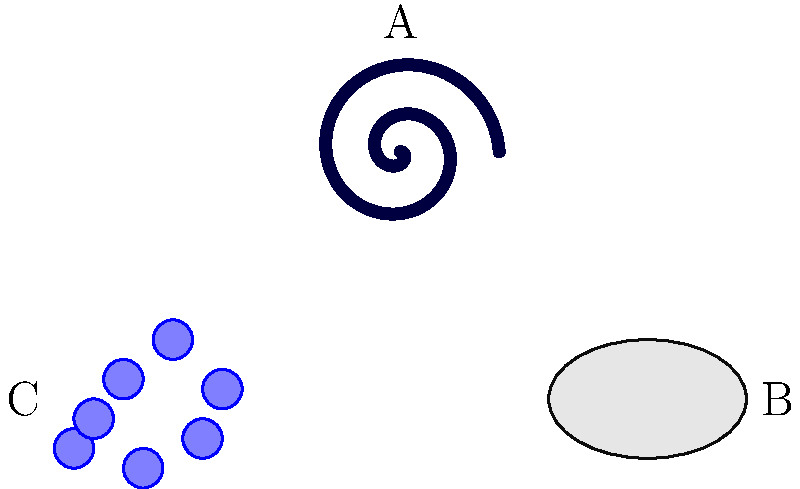As a botanist familiar with classification systems, consider the following galaxy types represented in the image above: A (spiral), B (elliptical), and C (irregular). Which of these galaxy types is most analogous to a plant species that has adapted to extreme environmental conditions, resulting in a non-uniform growth pattern? To answer this question, we need to consider the characteristics of each galaxy type and draw parallels to plant adaptations:

1. Spiral galaxies (A):
   - Have a distinct, organized structure with spiral arms
   - Analogous to plants with predictable, symmetrical growth patterns

2. Elliptical galaxies (B):
   - Smooth, featureless, and elliptical in shape
   - Similar to plants with uniform, rounded growth habits

3. Irregular galaxies (C):
   - Lack a definite shape or structure
   - Often result from gravitational interactions or mergers
   - Most closely resemble plants that have adapted to extreme conditions

Plants in extreme environments often develop irregular growth patterns due to:
   - Limited resources (water, nutrients, light)
   - Physical stressors (wind, temperature extremes)
   - Adaptation to unique ecological niches

These factors can lead to asymmetrical growth, unusual branching patterns, or other morphological adaptations that deviate from the typical form of the species.

The irregular galaxy (C) best represents this scenario, as it lacks a uniform structure and appears to have been shaped by external forces, much like a plant species adapting to challenging environmental conditions.
Answer: C (Irregular galaxy) 